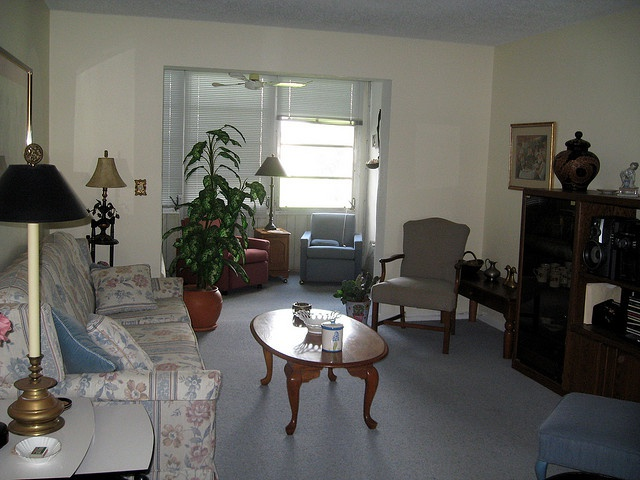Describe the objects in this image and their specific colors. I can see couch in gray, darkgray, and blue tones, potted plant in gray, black, darkgray, and maroon tones, couch in gray and black tones, dining table in gray, white, darkgray, and black tones, and chair in gray and black tones in this image. 